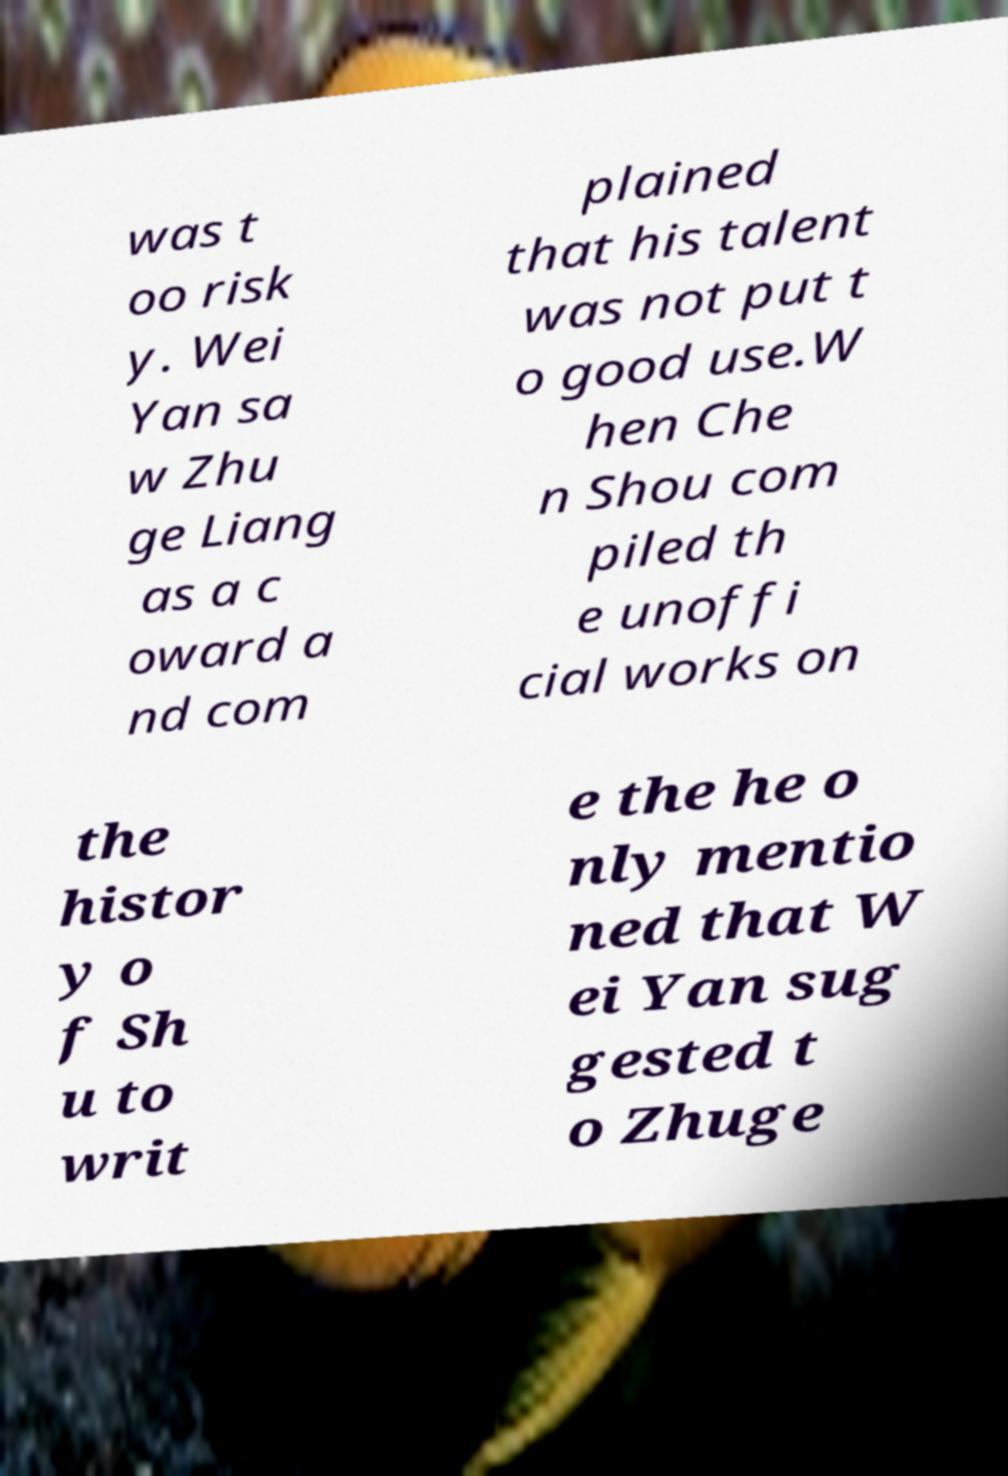I need the written content from this picture converted into text. Can you do that? was t oo risk y. Wei Yan sa w Zhu ge Liang as a c oward a nd com plained that his talent was not put t o good use.W hen Che n Shou com piled th e unoffi cial works on the histor y o f Sh u to writ e the he o nly mentio ned that W ei Yan sug gested t o Zhuge 